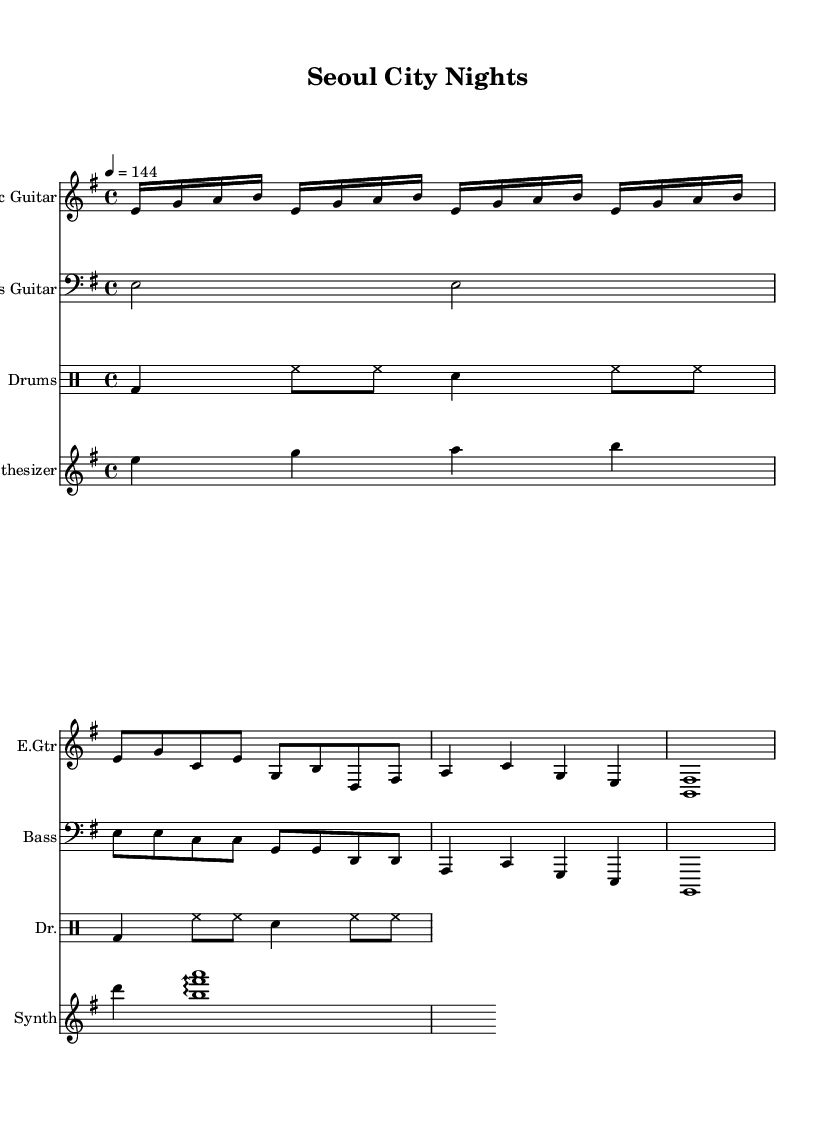What is the key signature of this music? The key signature is indicated at the beginning of the score, and it shows one sharp. This identifies the key of E minor.
Answer: E minor What is the time signature of this music? The time signature is shown at the beginning of the score as a fraction. It indicates that there are four beats in a measure, represented by the 4/4 signature.
Answer: 4/4 What is the tempo marking for this music? The tempo marking is located at the beginning of the score and indicates that the piece should be played at a speed of 144 beats per minute.
Answer: 144 How many measures are in the verse section? To determine the number of measures in the verse, I look at the section marked "Verse." Counting the measures present in this section shows that there are four measures total.
Answer: 4 What type of drum pattern is used in the main drum part? By analyzing the drumming part, it is clear that the pattern consists mainly of bass drum, hi-hat, and snare, which indicates a standard rock drumming pattern often found in rock music.
Answer: Rock What instrument plays the chorus melody? In the score, I see that the synthesizer part is designated to play the melody during the chorus section, as it specifies the notes for this section.
Answer: Synthesizer What is the structure of this piece? By looking at the overall layout of the sections labeled in the score, I can identify the piece's structure consisting of an Intro, Verse, Chorus, and Bridge. This is a typical form found in post-punk rock music.
Answer: Intro, Verse, Chorus, Bridge 